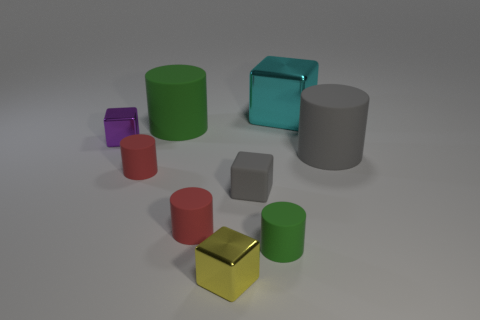What number of other things are there of the same size as the gray block?
Give a very brief answer. 5. There is a large matte thing that is behind the small purple shiny block; is its shape the same as the large thing in front of the purple metal cube?
Make the answer very short. Yes. How many things are big cyan metal cubes that are right of the small purple cube or small metallic things?
Your answer should be compact. 3. Is the cyan object the same size as the purple block?
Provide a short and direct response. No. What is the color of the large cylinder left of the rubber block?
Make the answer very short. Green. What size is the other green object that is made of the same material as the big green thing?
Your answer should be very brief. Small. There is a gray matte block; is its size the same as the cylinder that is to the right of the large cyan metal object?
Provide a succinct answer. No. There is a block that is behind the tiny purple metal thing; what is it made of?
Make the answer very short. Metal. There is a small shiny object that is to the right of the purple block; how many big cylinders are to the right of it?
Give a very brief answer. 1. Is there a purple object of the same shape as the tiny gray thing?
Your answer should be very brief. Yes. 